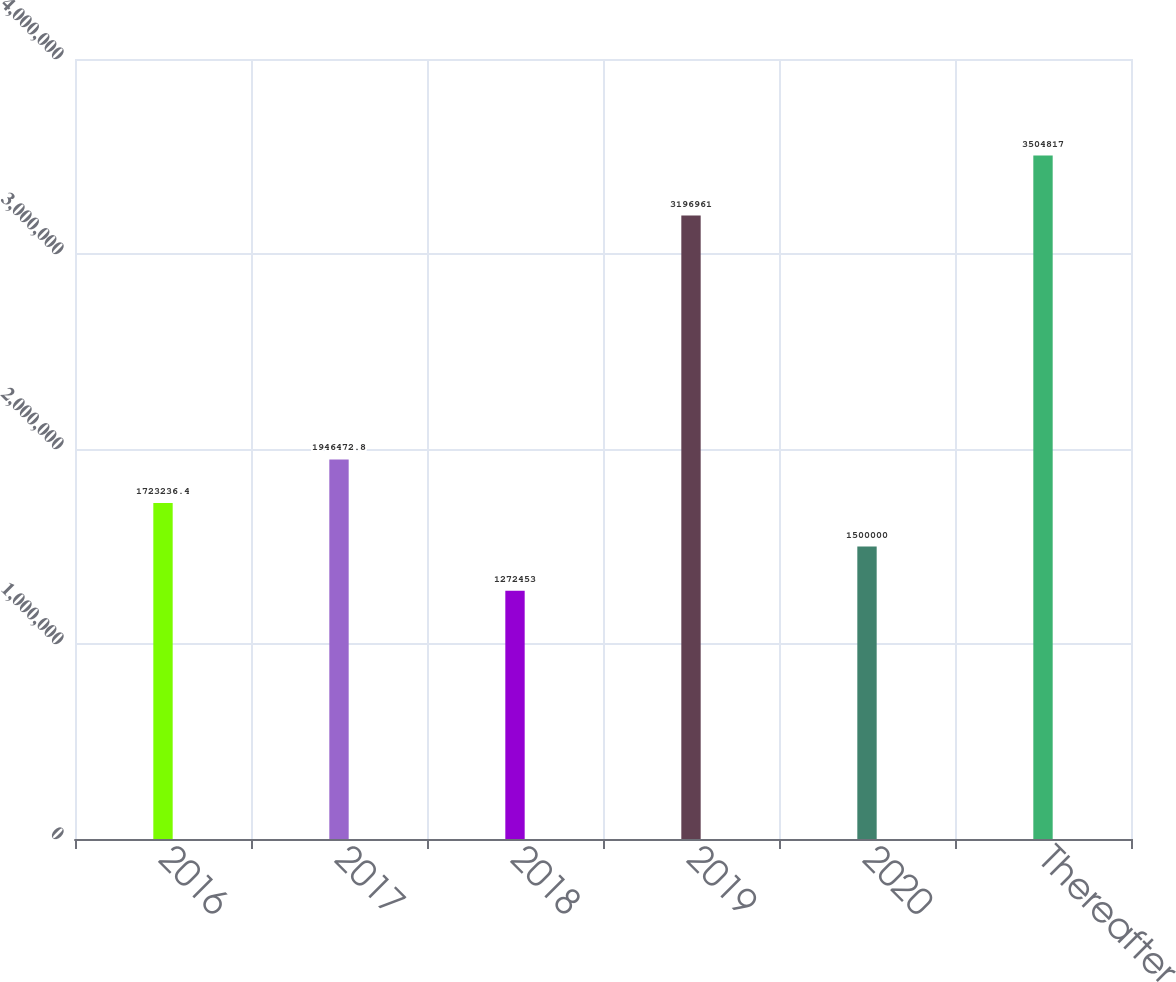Convert chart. <chart><loc_0><loc_0><loc_500><loc_500><bar_chart><fcel>2016<fcel>2017<fcel>2018<fcel>2019<fcel>2020<fcel>Thereafter<nl><fcel>1.72324e+06<fcel>1.94647e+06<fcel>1.27245e+06<fcel>3.19696e+06<fcel>1.5e+06<fcel>3.50482e+06<nl></chart> 